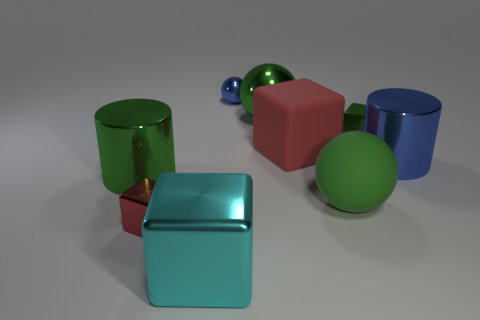There is a small block on the left side of the green metal sphere; does it have the same color as the rubber cube?
Your answer should be compact. Yes. Are there any red rubber cubes that have the same size as the green rubber sphere?
Keep it short and to the point. Yes. What number of other things are there of the same material as the large cyan cube
Provide a short and direct response. 6. What is the color of the metal thing that is both on the right side of the small red shiny object and in front of the large green matte sphere?
Provide a short and direct response. Cyan. Does the green ball in front of the green shiny sphere have the same material as the red thing that is right of the green metallic ball?
Ensure brevity in your answer.  Yes. Does the green sphere that is behind the rubber block have the same size as the green matte object?
Provide a succinct answer. Yes. There is a small sphere; is its color the same as the tiny metal cube that is right of the blue sphere?
Your answer should be very brief. No. The object that is the same color as the small metal sphere is what shape?
Provide a short and direct response. Cylinder. The cyan thing has what shape?
Make the answer very short. Cube. Does the rubber cube have the same color as the large metal ball?
Give a very brief answer. No. 